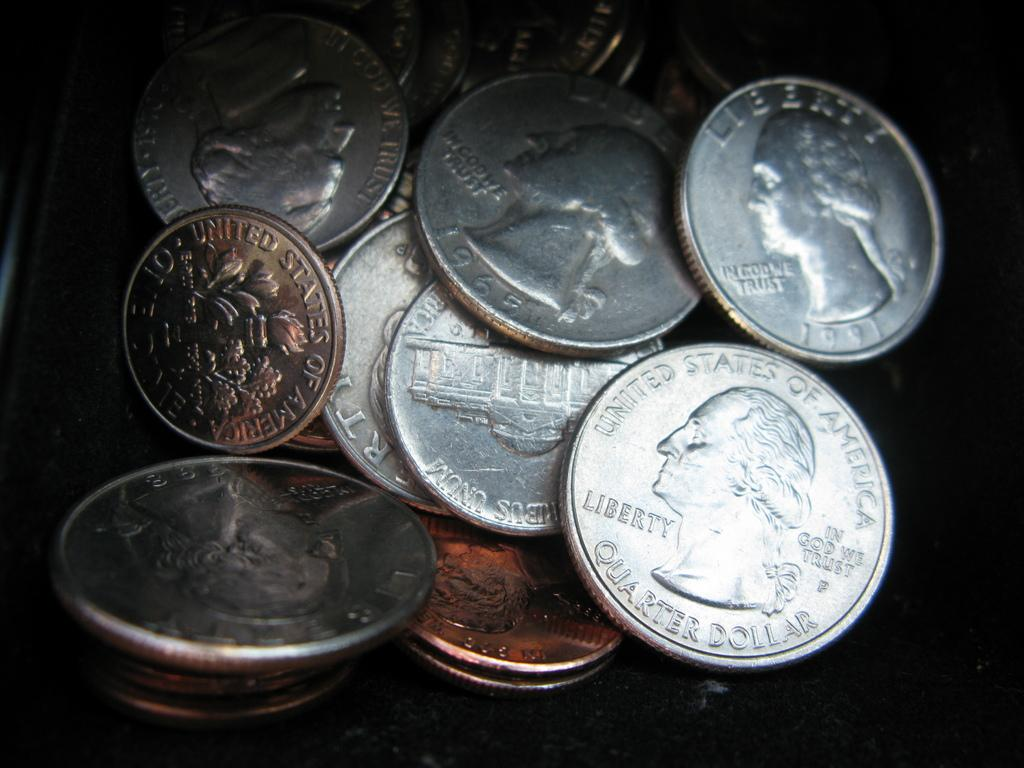Provide a one-sentence caption for the provided image. A variety of U.S. currencies in a pile which includes a penny, nickel, dime and quarter. 